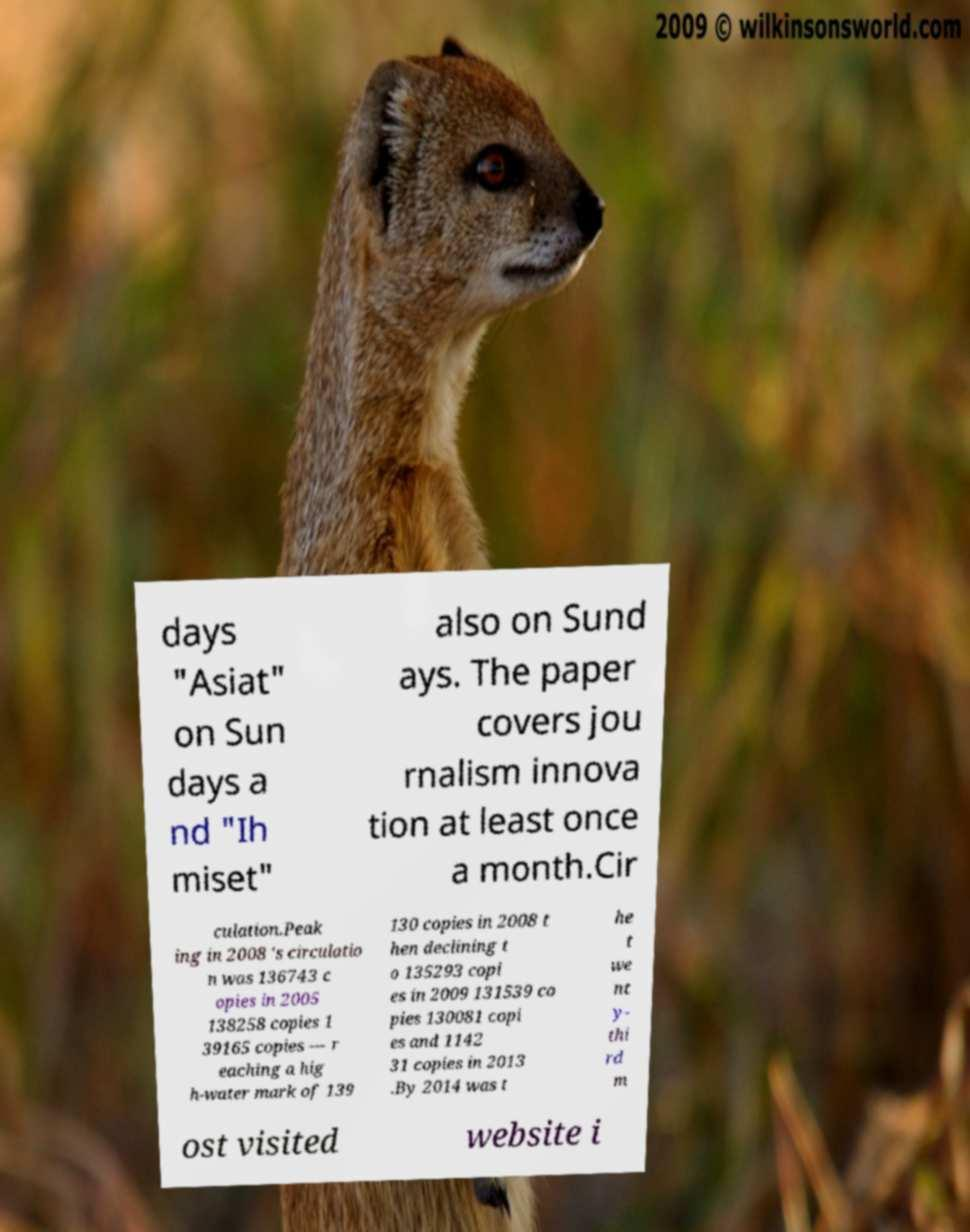Please identify and transcribe the text found in this image. days "Asiat" on Sun days a nd "Ih miset" also on Sund ays. The paper covers jou rnalism innova tion at least once a month.Cir culation.Peak ing in 2008 's circulatio n was 136743 c opies in 2005 138258 copies 1 39165 copies — r eaching a hig h-water mark of 139 130 copies in 2008 t hen declining t o 135293 copi es in 2009 131539 co pies 130081 copi es and 1142 31 copies in 2013 .By 2014 was t he t we nt y- thi rd m ost visited website i 